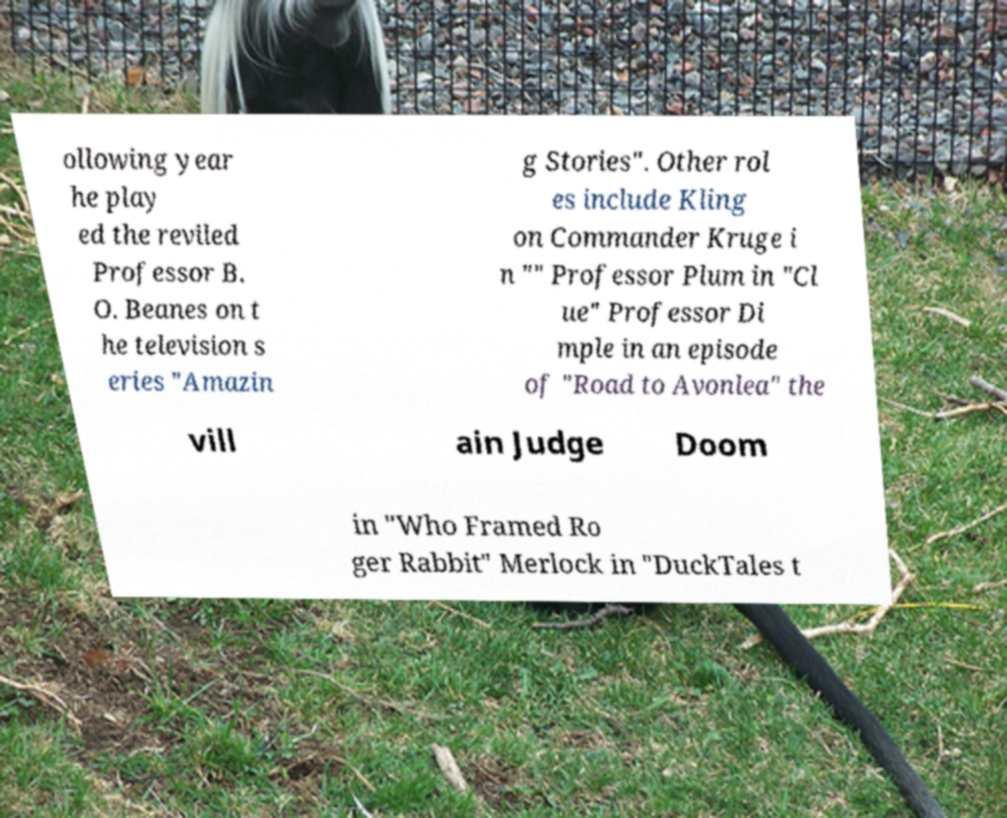Can you read and provide the text displayed in the image?This photo seems to have some interesting text. Can you extract and type it out for me? ollowing year he play ed the reviled Professor B. O. Beanes on t he television s eries "Amazin g Stories". Other rol es include Kling on Commander Kruge i n "" Professor Plum in "Cl ue" Professor Di mple in an episode of "Road to Avonlea" the vill ain Judge Doom in "Who Framed Ro ger Rabbit" Merlock in "DuckTales t 